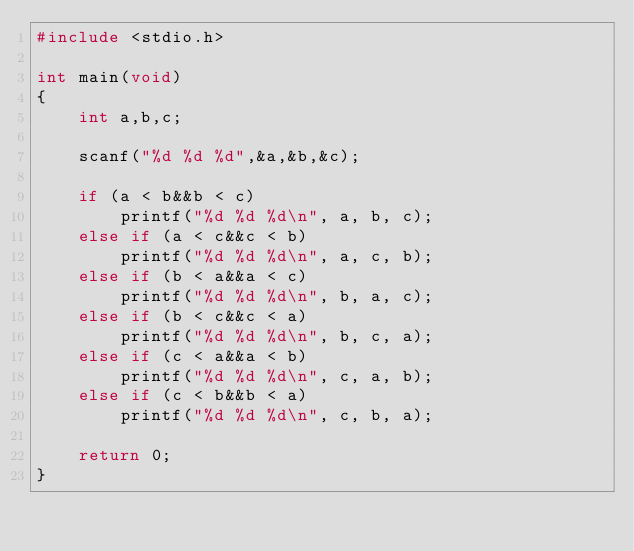<code> <loc_0><loc_0><loc_500><loc_500><_C_>#include <stdio.h>

int main(void)
{
	int a,b,c;

	scanf("%d %d %d",&a,&b,&c);

	if (a < b&&b < c)
		printf("%d %d %d\n", a, b, c);
	else if (a < c&&c < b)
		printf("%d %d %d\n", a, c, b);
	else if (b < a&&a < c)
		printf("%d %d %d\n", b, a, c);
	else if (b < c&&c < a)
		printf("%d %d %d\n", b, c, a);
	else if (c < a&&a < b)
		printf("%d %d %d\n", c, a, b);
	else if (c < b&&b < a)
		printf("%d %d %d\n", c, b, a);

	return 0;
}</code> 